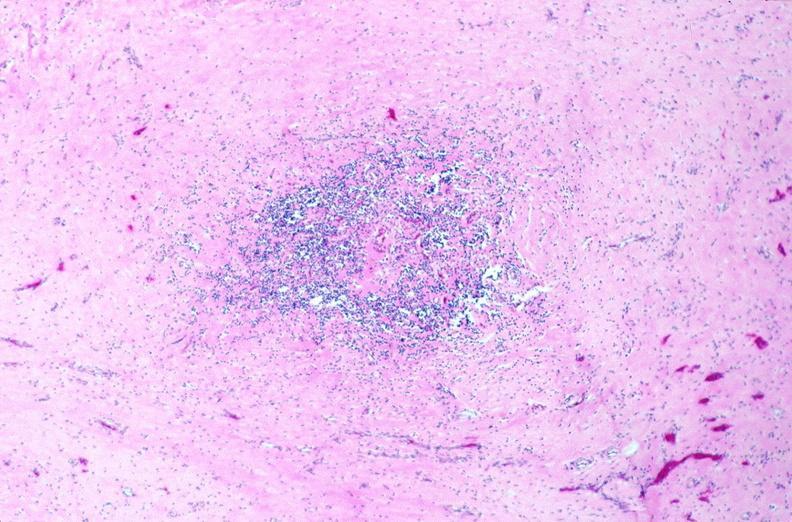does this typical thecoma with yellow foci show lymph nodes, nodular sclerosing hodgkins disease?
Answer the question using a single word or phrase. No 